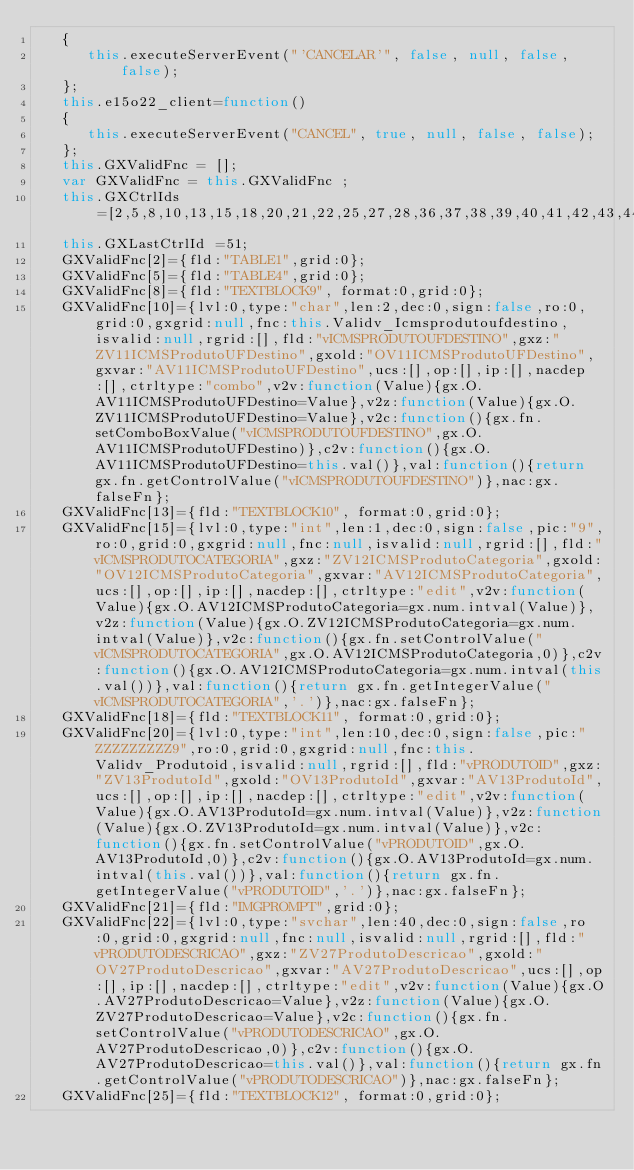<code> <loc_0><loc_0><loc_500><loc_500><_JavaScript_>   {
      this.executeServerEvent("'CANCELAR'", false, null, false, false);
   };
   this.e15o22_client=function()
   {
      this.executeServerEvent("CANCEL", true, null, false, false);
   };
   this.GXValidFnc = [];
   var GXValidFnc = this.GXValidFnc ;
   this.GXCtrlIds=[2,5,8,10,13,15,18,20,21,22,25,27,28,36,37,38,39,40,41,42,43,44,45,46,47,48,49,50,51];
   this.GXLastCtrlId =51;
   GXValidFnc[2]={fld:"TABLE1",grid:0};
   GXValidFnc[5]={fld:"TABLE4",grid:0};
   GXValidFnc[8]={fld:"TEXTBLOCK9", format:0,grid:0};
   GXValidFnc[10]={lvl:0,type:"char",len:2,dec:0,sign:false,ro:0,grid:0,gxgrid:null,fnc:this.Validv_Icmsprodutoufdestino,isvalid:null,rgrid:[],fld:"vICMSPRODUTOUFDESTINO",gxz:"ZV11ICMSProdutoUFDestino",gxold:"OV11ICMSProdutoUFDestino",gxvar:"AV11ICMSProdutoUFDestino",ucs:[],op:[],ip:[],nacdep:[],ctrltype:"combo",v2v:function(Value){gx.O.AV11ICMSProdutoUFDestino=Value},v2z:function(Value){gx.O.ZV11ICMSProdutoUFDestino=Value},v2c:function(){gx.fn.setComboBoxValue("vICMSPRODUTOUFDESTINO",gx.O.AV11ICMSProdutoUFDestino)},c2v:function(){gx.O.AV11ICMSProdutoUFDestino=this.val()},val:function(){return gx.fn.getControlValue("vICMSPRODUTOUFDESTINO")},nac:gx.falseFn};
   GXValidFnc[13]={fld:"TEXTBLOCK10", format:0,grid:0};
   GXValidFnc[15]={lvl:0,type:"int",len:1,dec:0,sign:false,pic:"9",ro:0,grid:0,gxgrid:null,fnc:null,isvalid:null,rgrid:[],fld:"vICMSPRODUTOCATEGORIA",gxz:"ZV12ICMSProdutoCategoria",gxold:"OV12ICMSProdutoCategoria",gxvar:"AV12ICMSProdutoCategoria",ucs:[],op:[],ip:[],nacdep:[],ctrltype:"edit",v2v:function(Value){gx.O.AV12ICMSProdutoCategoria=gx.num.intval(Value)},v2z:function(Value){gx.O.ZV12ICMSProdutoCategoria=gx.num.intval(Value)},v2c:function(){gx.fn.setControlValue("vICMSPRODUTOCATEGORIA",gx.O.AV12ICMSProdutoCategoria,0)},c2v:function(){gx.O.AV12ICMSProdutoCategoria=gx.num.intval(this.val())},val:function(){return gx.fn.getIntegerValue("vICMSPRODUTOCATEGORIA",'.')},nac:gx.falseFn};
   GXValidFnc[18]={fld:"TEXTBLOCK11", format:0,grid:0};
   GXValidFnc[20]={lvl:0,type:"int",len:10,dec:0,sign:false,pic:"ZZZZZZZZZ9",ro:0,grid:0,gxgrid:null,fnc:this.Validv_Produtoid,isvalid:null,rgrid:[],fld:"vPRODUTOID",gxz:"ZV13ProdutoId",gxold:"OV13ProdutoId",gxvar:"AV13ProdutoId",ucs:[],op:[],ip:[],nacdep:[],ctrltype:"edit",v2v:function(Value){gx.O.AV13ProdutoId=gx.num.intval(Value)},v2z:function(Value){gx.O.ZV13ProdutoId=gx.num.intval(Value)},v2c:function(){gx.fn.setControlValue("vPRODUTOID",gx.O.AV13ProdutoId,0)},c2v:function(){gx.O.AV13ProdutoId=gx.num.intval(this.val())},val:function(){return gx.fn.getIntegerValue("vPRODUTOID",'.')},nac:gx.falseFn};
   GXValidFnc[21]={fld:"IMGPROMPT",grid:0};
   GXValidFnc[22]={lvl:0,type:"svchar",len:40,dec:0,sign:false,ro:0,grid:0,gxgrid:null,fnc:null,isvalid:null,rgrid:[],fld:"vPRODUTODESCRICAO",gxz:"ZV27ProdutoDescricao",gxold:"OV27ProdutoDescricao",gxvar:"AV27ProdutoDescricao",ucs:[],op:[],ip:[],nacdep:[],ctrltype:"edit",v2v:function(Value){gx.O.AV27ProdutoDescricao=Value},v2z:function(Value){gx.O.ZV27ProdutoDescricao=Value},v2c:function(){gx.fn.setControlValue("vPRODUTODESCRICAO",gx.O.AV27ProdutoDescricao,0)},c2v:function(){gx.O.AV27ProdutoDescricao=this.val()},val:function(){return gx.fn.getControlValue("vPRODUTODESCRICAO")},nac:gx.falseFn};
   GXValidFnc[25]={fld:"TEXTBLOCK12", format:0,grid:0};</code> 